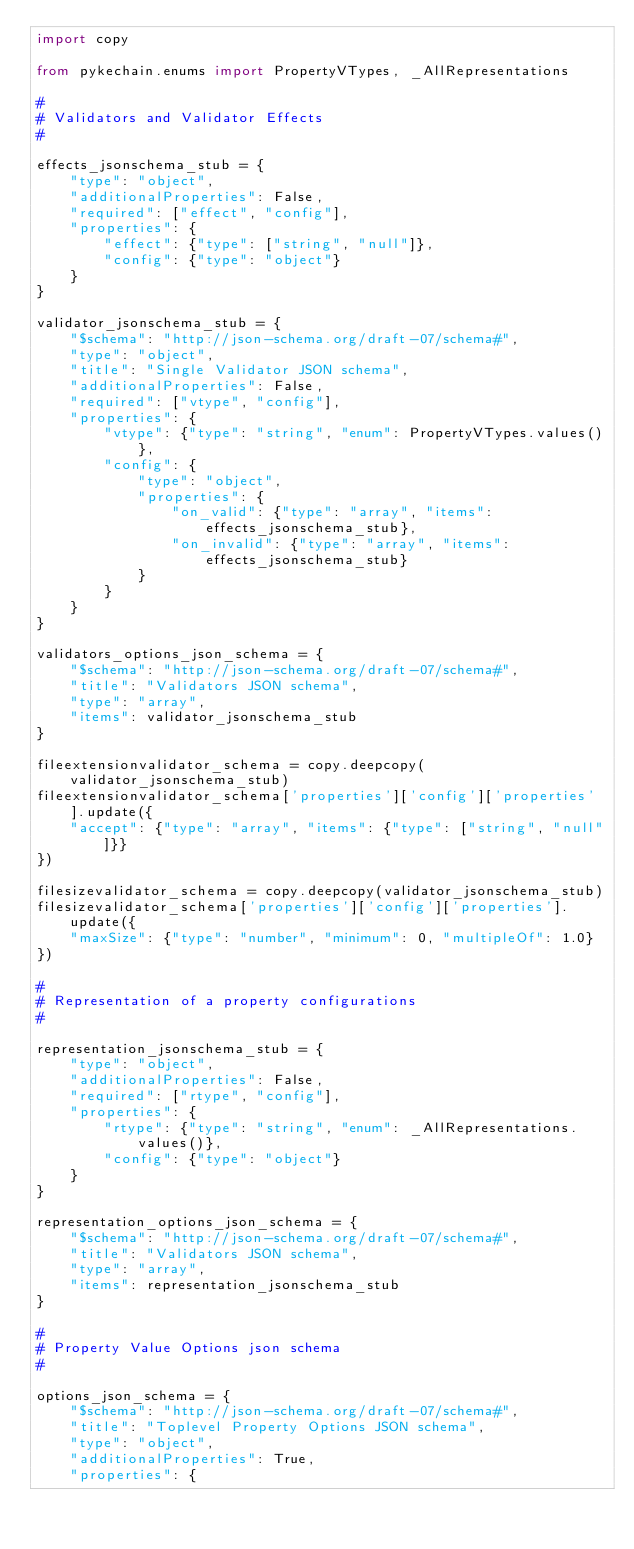Convert code to text. <code><loc_0><loc_0><loc_500><loc_500><_Python_>import copy

from pykechain.enums import PropertyVTypes, _AllRepresentations

#
# Validators and Validator Effects
#

effects_jsonschema_stub = {
    "type": "object",
    "additionalProperties": False,
    "required": ["effect", "config"],
    "properties": {
        "effect": {"type": ["string", "null"]},
        "config": {"type": "object"}
    }
}

validator_jsonschema_stub = {
    "$schema": "http://json-schema.org/draft-07/schema#",
    "type": "object",
    "title": "Single Validator JSON schema",
    "additionalProperties": False,
    "required": ["vtype", "config"],
    "properties": {
        "vtype": {"type": "string", "enum": PropertyVTypes.values()},
        "config": {
            "type": "object",
            "properties": {
                "on_valid": {"type": "array", "items": effects_jsonschema_stub},
                "on_invalid": {"type": "array", "items": effects_jsonschema_stub}
            }
        }
    }
}

validators_options_json_schema = {
    "$schema": "http://json-schema.org/draft-07/schema#",
    "title": "Validators JSON schema",
    "type": "array",
    "items": validator_jsonschema_stub
}

fileextensionvalidator_schema = copy.deepcopy(validator_jsonschema_stub)
fileextensionvalidator_schema['properties']['config']['properties'].update({
    "accept": {"type": "array", "items": {"type": ["string", "null"]}}
})

filesizevalidator_schema = copy.deepcopy(validator_jsonschema_stub)
filesizevalidator_schema['properties']['config']['properties'].update({
    "maxSize": {"type": "number", "minimum": 0, "multipleOf": 1.0}
})

#
# Representation of a property configurations
#

representation_jsonschema_stub = {
    "type": "object",
    "additionalProperties": False,
    "required": ["rtype", "config"],
    "properties": {
        "rtype": {"type": "string", "enum": _AllRepresentations.values()},
        "config": {"type": "object"}
    }
}

representation_options_json_schema = {
    "$schema": "http://json-schema.org/draft-07/schema#",
    "title": "Validators JSON schema",
    "type": "array",
    "items": representation_jsonschema_stub
}

#
# Property Value Options json schema
#

options_json_schema = {
    "$schema": "http://json-schema.org/draft-07/schema#",
    "title": "Toplevel Property Options JSON schema",
    "type": "object",
    "additionalProperties": True,
    "properties": {</code> 